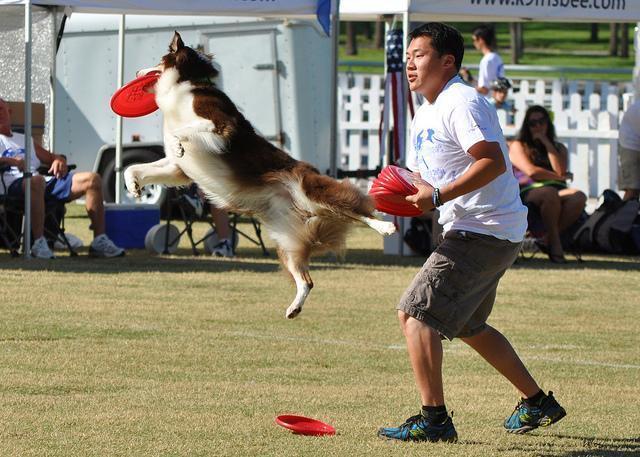How many chairs can you see?
Give a very brief answer. 2. How many people are there?
Give a very brief answer. 4. How many dogs can be seen?
Give a very brief answer. 1. How many backpacks are there?
Give a very brief answer. 1. How many skateboards are tipped up?
Give a very brief answer. 0. 